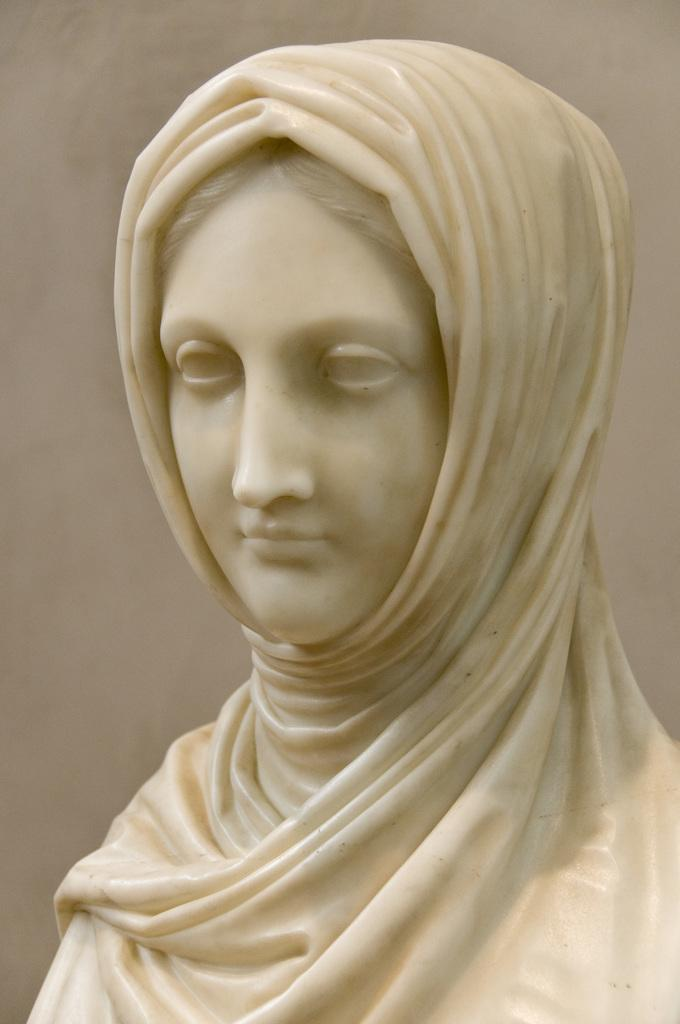What is the main subject of the image? There is a sculpture of a woman in the image. How many yaks can be seen in the image? There are no yaks present in the image; it features a sculpture of a woman. What type of hole is visible in the image? There is no hole present in the image; it features a sculpture of a woman. 